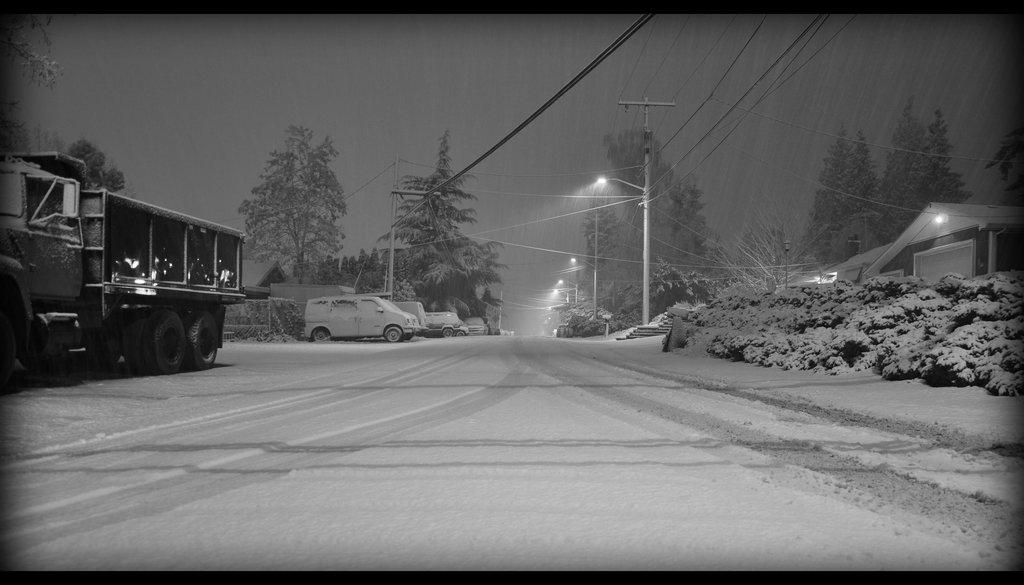What is the main subject in the middle of the image? There is a truck in the middle of the image. What else can be seen on the road in the image? There are vehicles on the road. What can be observed about the time of day in the image? The image is taken during night. What is visible in the background of the image? There are houses, trees, poles, wires, and the sky visible in the background of the image. Where is the zoo located in the image? There is no zoo present in the image. What type of coil is wrapped around the poles in the image? There are no coils visible in the image; there are only wires and poles present. 